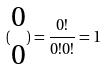Convert formula to latex. <formula><loc_0><loc_0><loc_500><loc_500>( \begin{matrix} 0 \\ 0 \end{matrix} ) = \frac { 0 ! } { 0 ! 0 ! } = 1</formula> 